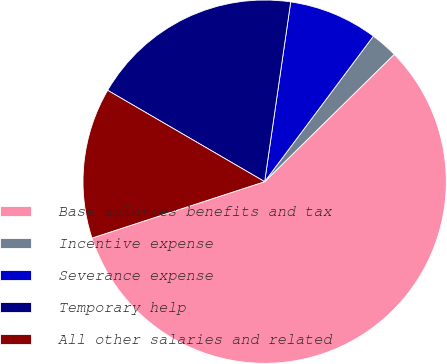<chart> <loc_0><loc_0><loc_500><loc_500><pie_chart><fcel>Base salaries benefits and tax<fcel>Incentive expense<fcel>Severance expense<fcel>Temporary help<fcel>All other salaries and related<nl><fcel>57.33%<fcel>2.43%<fcel>7.92%<fcel>18.9%<fcel>13.41%<nl></chart> 